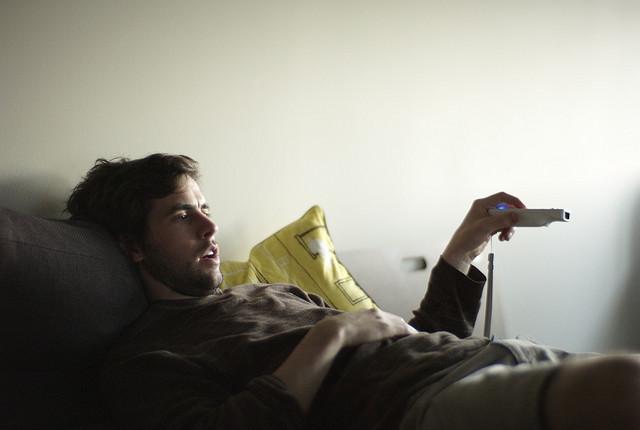What does this person have in their hand?
Be succinct. Remote. What is behind the man's head?
Short answer required. Pillow. Does this guy look like he knows what he is doing?
Be succinct. Yes. Is this person standing up?
Short answer required. No. 